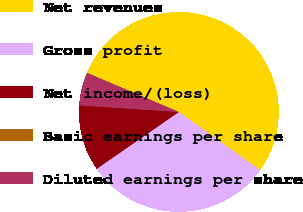Convert chart. <chart><loc_0><loc_0><loc_500><loc_500><pie_chart><fcel>Net revenues<fcel>Gross profit<fcel>Net income/(loss)<fcel>Basic earnings per share<fcel>Diluted earnings per share<nl><fcel>53.47%<fcel>30.49%<fcel>10.69%<fcel>0.0%<fcel>5.35%<nl></chart> 